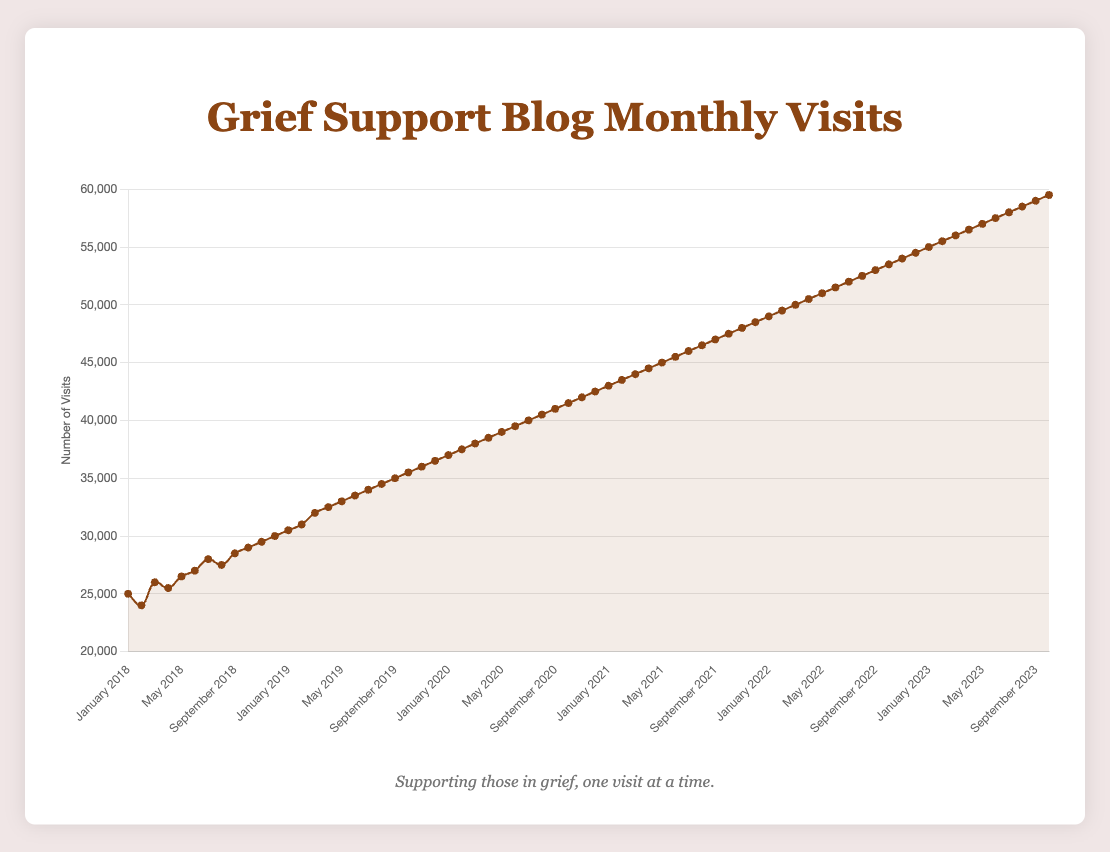What is the trend in the monthly website visits over the last five years? The line plot shows that the number of visits has been steadily increasing over the last five years. Starting at 25,000 visits in January 2018 and reaching approximately 59,500 visits in October 2023, the trend demonstrates a continuous upward slope.
Answer: Increasing What was the highest number of visits recorded within a single month, and when did it occur? The highest number of visits, approximately 59,500, was recorded in October 2023. This can be identified as the peak point on the line plot.
Answer: 59,500 in October 2023 Compare the number of visits in January 2018 and January 2023. Which year had more visits and by how much? In January 2018, there were 25,000 visits, while in January 2023, there were 55,000 visits. January 2023 had 30,000 more visits than January 2018.
Answer: January 2023 had 30,000 more visits What is the average number of monthly visits in the year 2021? To find the average number of visits in 2021, sum the monthly visits for each month of that year and then divide by 12. The visits are 43000, 43500, 44000, 44500, 45000, 45500, 46000, 46500, 47000, 47500, 48000, and 48500. Adding these gives 547500. Dividing 547500 by 12 gives an average of approximately 45,625 visits.
Answer: 45,625 Between which two consecutive months was the biggest increase in visits observed? To find the biggest increase, examine the differences between consecutive months across the entire dataset. The largest difference between consecutive months is from December 2022 to January 2023, where it increased from 54,500 to 55,000, an increase of 5,000 visits.
Answer: December 2022 to January 2023 Did the website ever experience a decrease in visits between any two consecutive months? If so, when? A close inspection of the line plot shows that there was a slight decrease in visits between January and February 2018, from 25,000 to 24,000.
Answer: January 2018 to February 2018 What is the overall percentage increase in the number of monthly visits from January 2018 to October 2023? In January 2018, the visits were 25,000. In October 2023, the visits were 59,500. The percentage increase is calculated as ((59,500 - 25,000) / 25,000) * 100%. This results in a percentage increase of 138%.
Answer: 138% What is the median number of visits over the period from January 2021 to December 2021? Listing all the monthly visits for 2021 in order: 43000, 43500, 44000, 44500, 45000, 45500, 46000, 46500, 47000, 47500, 48000, 48500. With 12 data points, the median will be the average of the 6th and 7th values. Thus, the median is (45500 + 46000) / 2 = 45750.
Answer: 45,750 Which year saw the most significant overall increase in visits compared to the previous year? By comparing the increase each year:
- 2018 to 2019: 36500 - 30000 = 6500
- 2019 to 2020: 42500 - 36500 = 6000
- 2020 to 2021: 48500 - 42500 = 6000
- 2021 to 2022: 54500 - 48500 = 6000
- 2022 to 2023 (up to October): 59500 - 54500 = 5000 (10 months, annual total would be higher)
The year 2018 to 2019 saw the most significant increase of 6,500 visits.
Answer: 2018 to 2019, with 6,500 visits What was the monthly growth rate in visits from July 2023 to October 2023? From July 2023 to October 2023, the visits increased from 58,000 to 59,500 over three months. The growth rate per month is (59,500 - 58,000) / 3 = 500 visits per month.
Answer: 500 visits per month 